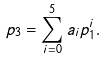Convert formula to latex. <formula><loc_0><loc_0><loc_500><loc_500>p _ { 3 } = \sum _ { i = 0 } ^ { 5 } a _ { i } p _ { 1 } ^ { i } .</formula> 